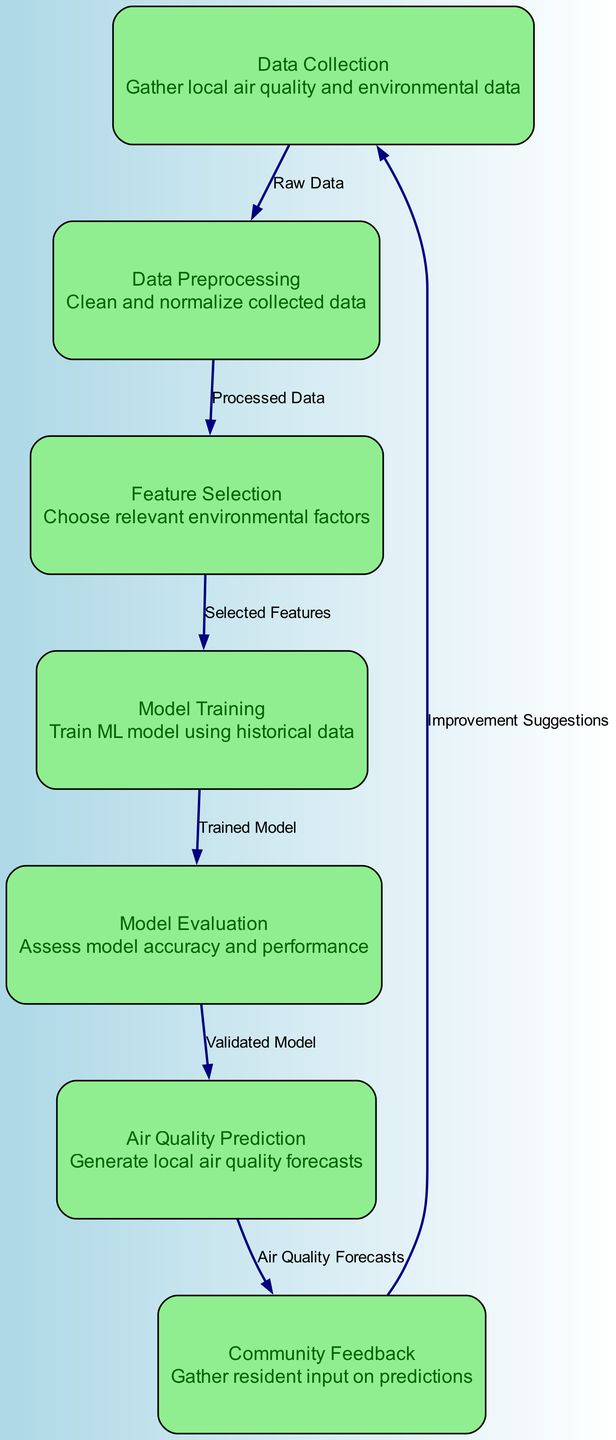What is the first node in the diagram? The first node in the diagram is "Data Collection," which is where the process begins by gathering local air quality and environmental data.
Answer: Data Collection How many nodes are in the diagram? The diagram contains seven nodes, as listed from Data Collection to Community Feedback.
Answer: 7 What is the last step in the process? The last step in the process is "Community Feedback," where resident input on predictions is gathered.
Answer: Community Feedback What do you get from the "Model Evaluation" node? From the "Model Evaluation" node, you get a "Validated Model," which confirms that the trained model has been assessed for accuracy and performance.
Answer: Validated Model What is the connection between "Air Quality Prediction" and "Community Feedback"? The connection between "Air Quality Prediction" and "Community Feedback" is that air quality forecasts lead to gathering resident input on those predictions.
Answer: Air Quality Forecasts What is the purpose of the "Feature Selection" node? The purpose of the "Feature Selection" node is to choose relevant environmental factors that will be used for model training.
Answer: Choose relevant environmental factors How does feedback influence the process? Feedback influences the process by providing "Improvement Suggestions" that can be collected from residents, which may enhance data collection in future iterations.
Answer: Improvement Suggestions What type of data is processed in "Data Preprocessing"? In "Data Preprocessing," the raw data collected during the "Data Collection" phase is cleaned and normalized to prepare it for analysis.
Answer: Clean and normalize collected data What output does "Model Training" produce? "Model Training" produces a "Trained Model," which is the output that results from using historical data to train the machine learning model.
Answer: Trained Model 